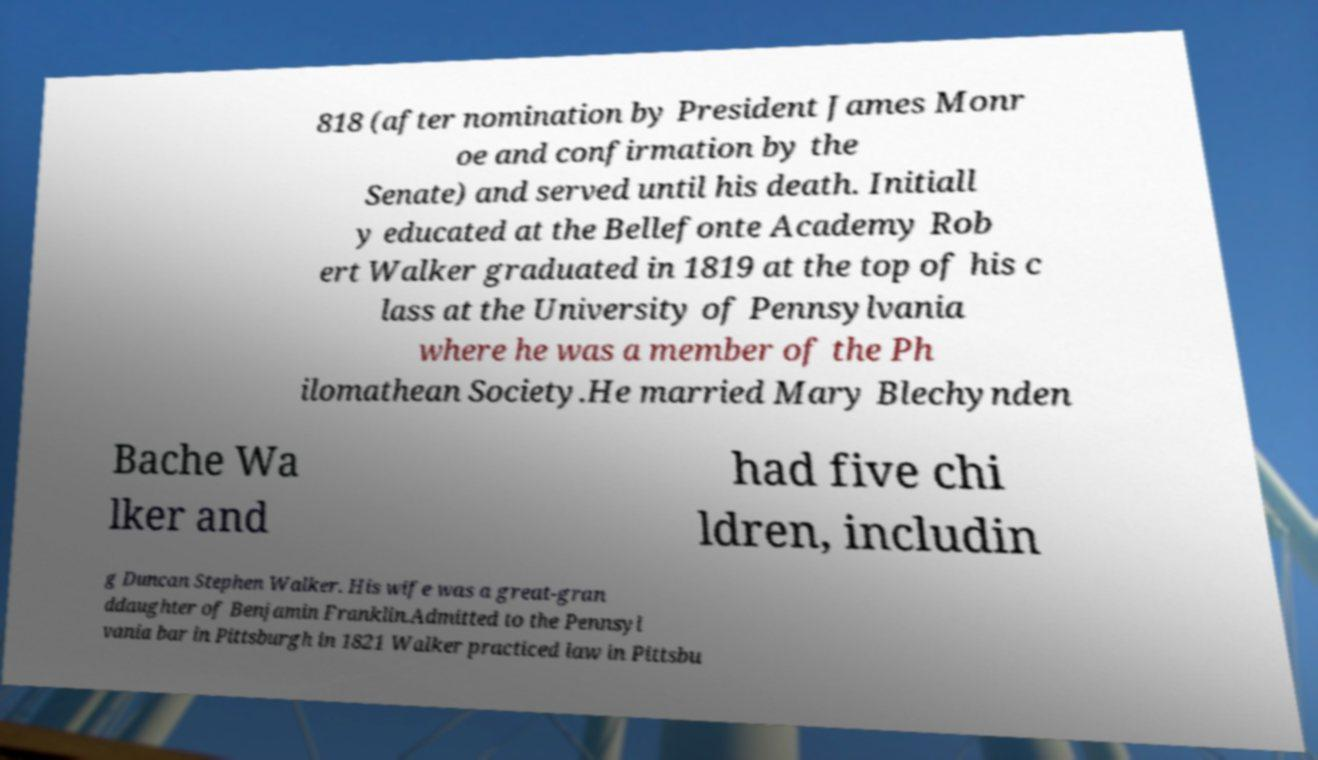Could you extract and type out the text from this image? 818 (after nomination by President James Monr oe and confirmation by the Senate) and served until his death. Initiall y educated at the Bellefonte Academy Rob ert Walker graduated in 1819 at the top of his c lass at the University of Pennsylvania where he was a member of the Ph ilomathean Society.He married Mary Blechynden Bache Wa lker and had five chi ldren, includin g Duncan Stephen Walker. His wife was a great-gran ddaughter of Benjamin Franklin.Admitted to the Pennsyl vania bar in Pittsburgh in 1821 Walker practiced law in Pittsbu 